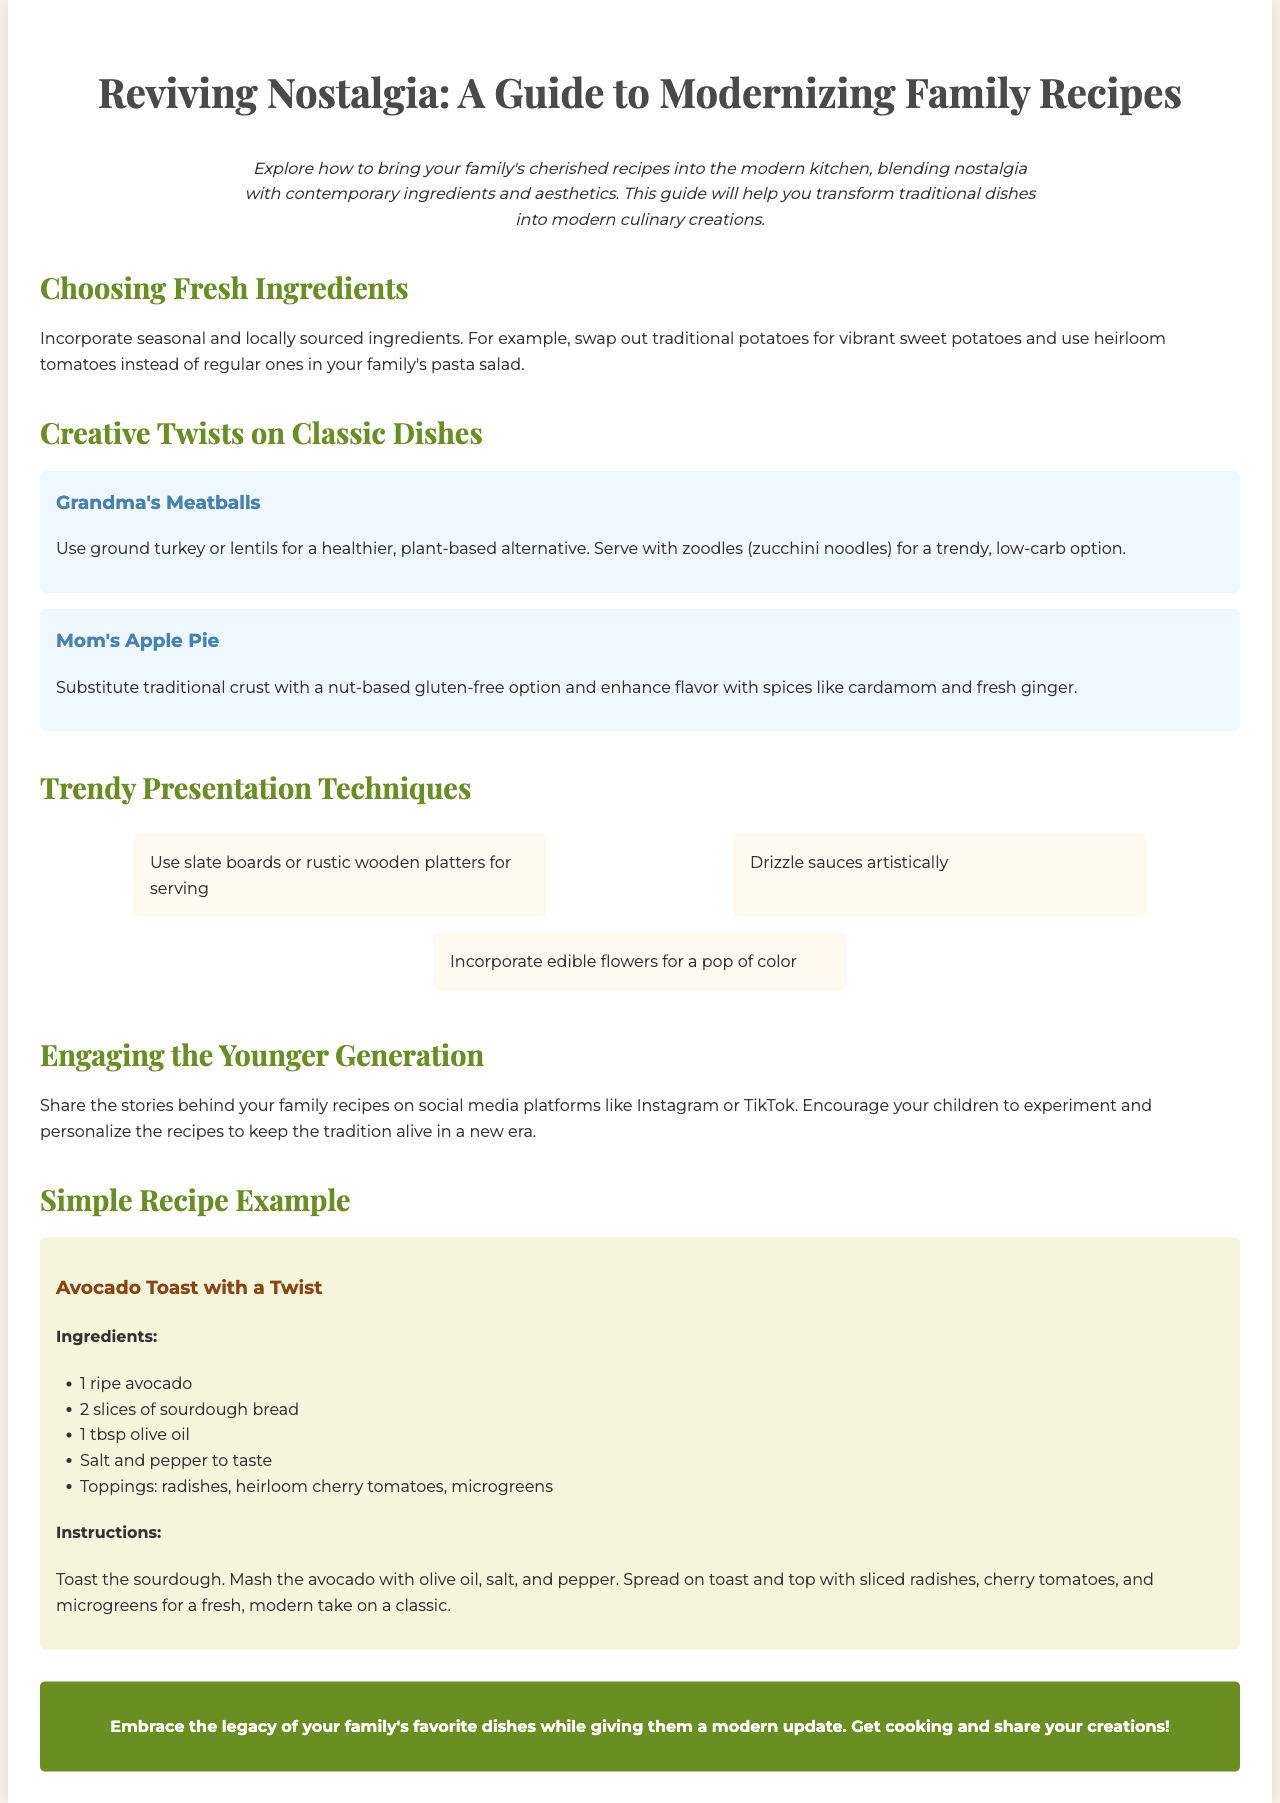What is the title of the brochure? The title of the brochure is prominently displayed at the top and indicates the main focus of the content, which is about modernizing family recipes.
Answer: Reviving Nostalgia: A Guide to Modernizing Family Recipes What is an example of a modern twist on Grandma's Meatballs? The document provides an alternative option for the dish, emphasizing healthier choices and trendy presentations.
Answer: Ground turkey or lentils Which ingredient is suggested for use instead of traditional potatoes? The brochure encourages using ingredients that are more vibrant and nutritious in modern cooking.
Answer: Sweet potatoes What kind of boards are recommended for serving food? The suggested serving items aim to enhance the presentation of the dishes in a trendy way.
Answer: Slate boards or rustic wooden platters How are family recipes suggested to be shared with the younger generation? The document highlights engaging modern platforms to encourage the continuation of family culinary traditions.
Answer: Social media platforms like Instagram or TikTok What is the main ingredient in the recipe for Avocado Toast? The recipe section specifies the critical ingredient necessary for preparing this dish.
Answer: Avocado What should be used for the crust in Mom's Apple Pie? This reflects a change towards healthier and more modern cooking techniques.
Answer: Nut-based gluten-free option How many tips are provided for trendy presentation techniques? The document includes specific recommendations for how to present food, indicating a focus on aesthetics in modern cooking.
Answer: Three tips 